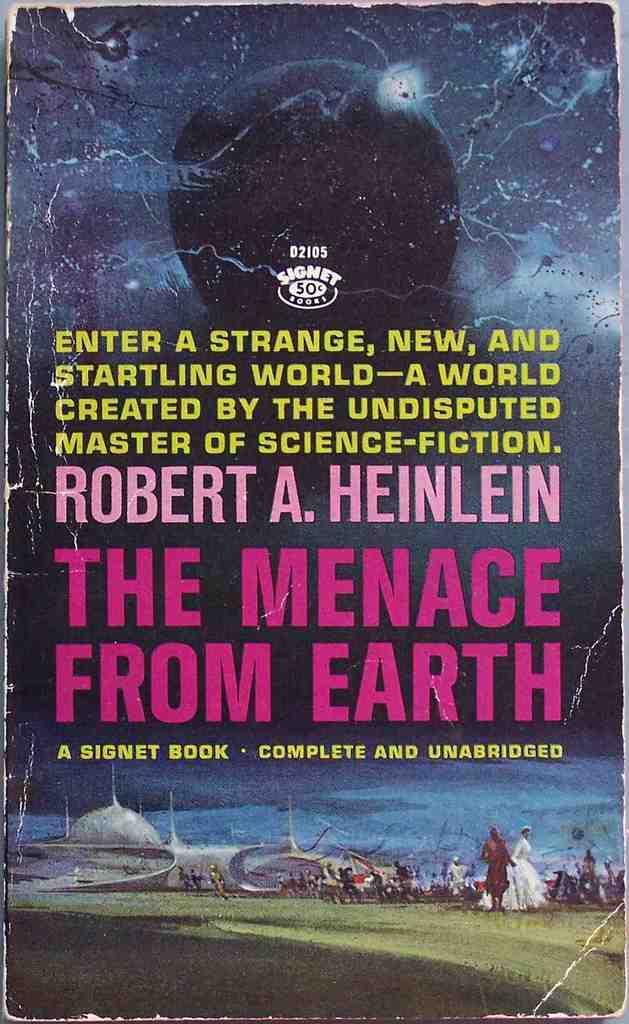<image>
Summarize the visual content of the image. A worn book called The Menace From Earth has a tattered cover. 